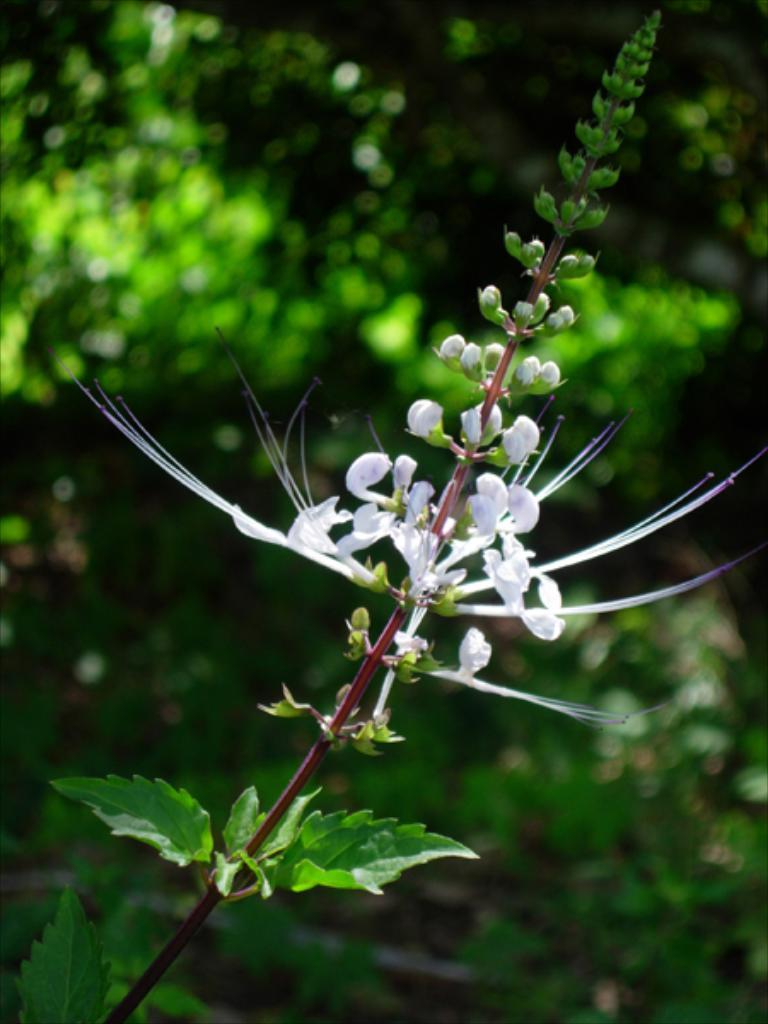What is present in the image? There is a plant in the image. What specific features can be observed on the plant? The plant has flowers, buds, and leaves. How would you describe the background of the image? The background of the image is blurry. Can you see the pig smiling next to the plant in the image? There is no pig or any indication of a smile in the image; it features a plant with flowers, buds, and leaves against a blurry background. 